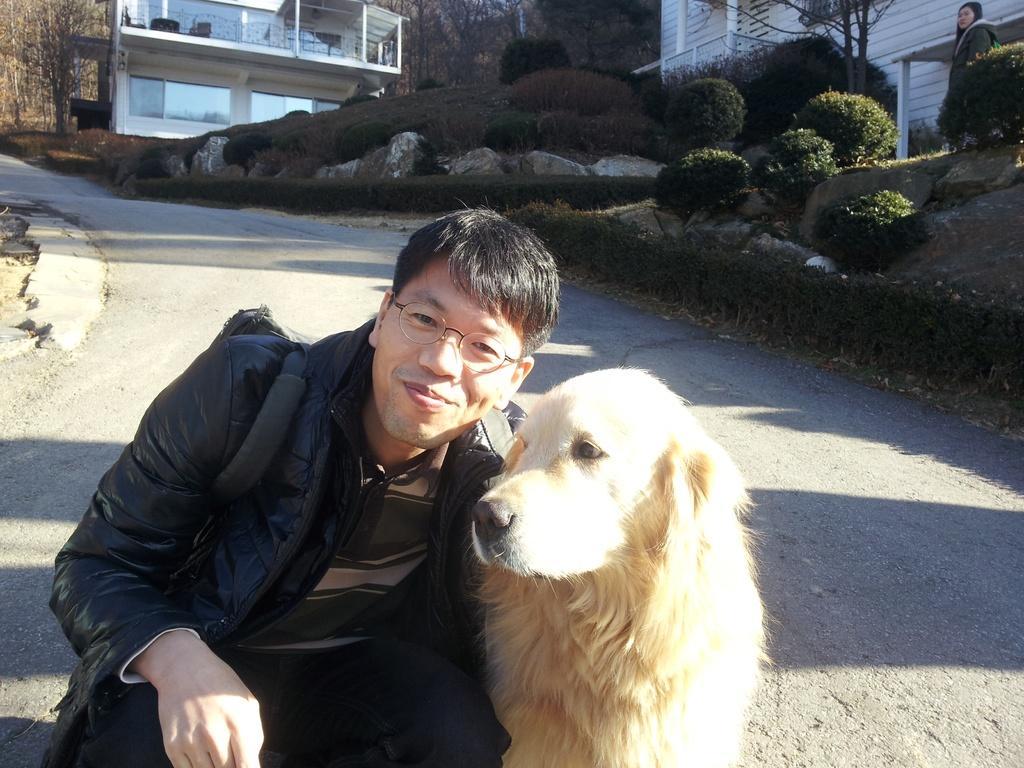Can you describe this image briefly? In this image we can see a man sitting and smiling, next to him there is a dog. In the background there are buildings, trees, bushes and a lady. 